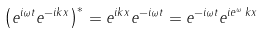<formula> <loc_0><loc_0><loc_500><loc_500>\left ( e ^ { i \omega t } e ^ { - i k x } \right ) ^ { * } = e ^ { i k x } e ^ { - i \omega t } = e ^ { - i \omega t } e ^ { i e ^ { \omega } \, k x }</formula> 